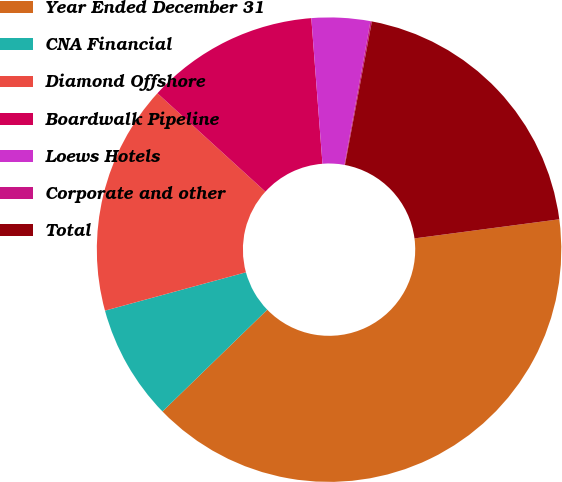<chart> <loc_0><loc_0><loc_500><loc_500><pie_chart><fcel>Year Ended December 31<fcel>CNA Financial<fcel>Diamond Offshore<fcel>Boardwalk Pipeline<fcel>Loews Hotels<fcel>Corporate and other<fcel>Total<nl><fcel>39.82%<fcel>8.04%<fcel>15.99%<fcel>12.02%<fcel>4.07%<fcel>0.1%<fcel>19.96%<nl></chart> 